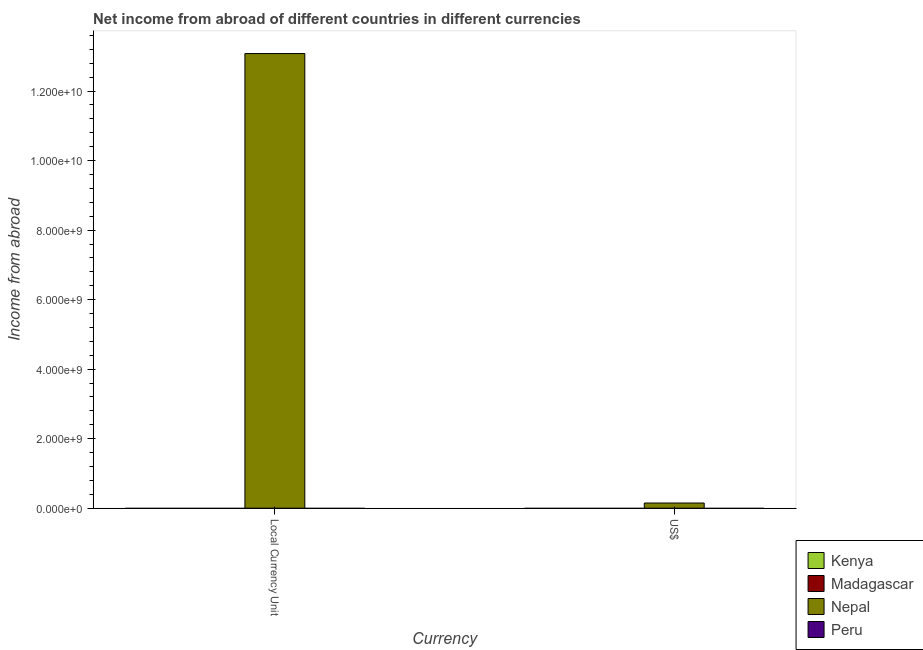How many different coloured bars are there?
Your response must be concise. 1. Are the number of bars per tick equal to the number of legend labels?
Ensure brevity in your answer.  No. What is the label of the 2nd group of bars from the left?
Offer a terse response. US$. What is the income from abroad in constant 2005 us$ in Peru?
Keep it short and to the point. 0. Across all countries, what is the maximum income from abroad in us$?
Your answer should be very brief. 1.49e+08. Across all countries, what is the minimum income from abroad in us$?
Give a very brief answer. 0. In which country was the income from abroad in constant 2005 us$ maximum?
Your answer should be compact. Nepal. What is the total income from abroad in constant 2005 us$ in the graph?
Provide a short and direct response. 1.31e+1. What is the difference between the income from abroad in us$ in Peru and the income from abroad in constant 2005 us$ in Kenya?
Keep it short and to the point. 0. What is the average income from abroad in us$ per country?
Ensure brevity in your answer.  3.72e+07. What is the difference between the income from abroad in constant 2005 us$ and income from abroad in us$ in Nepal?
Provide a short and direct response. 1.29e+1. In how many countries, is the income from abroad in constant 2005 us$ greater than 4000000000 units?
Ensure brevity in your answer.  1. Are the values on the major ticks of Y-axis written in scientific E-notation?
Your response must be concise. Yes. Does the graph contain any zero values?
Ensure brevity in your answer.  Yes. Does the graph contain grids?
Give a very brief answer. No. Where does the legend appear in the graph?
Keep it short and to the point. Bottom right. How are the legend labels stacked?
Offer a very short reply. Vertical. What is the title of the graph?
Offer a terse response. Net income from abroad of different countries in different currencies. What is the label or title of the X-axis?
Offer a very short reply. Currency. What is the label or title of the Y-axis?
Give a very brief answer. Income from abroad. What is the Income from abroad in Nepal in Local Currency Unit?
Provide a short and direct response. 1.31e+1. What is the Income from abroad in Peru in Local Currency Unit?
Offer a terse response. 0. What is the Income from abroad of Nepal in US$?
Give a very brief answer. 1.49e+08. Across all Currency, what is the maximum Income from abroad in Nepal?
Make the answer very short. 1.31e+1. Across all Currency, what is the minimum Income from abroad of Nepal?
Give a very brief answer. 1.49e+08. What is the total Income from abroad of Kenya in the graph?
Give a very brief answer. 0. What is the total Income from abroad in Nepal in the graph?
Provide a short and direct response. 1.32e+1. What is the difference between the Income from abroad of Nepal in Local Currency Unit and that in US$?
Your answer should be compact. 1.29e+1. What is the average Income from abroad in Kenya per Currency?
Make the answer very short. 0. What is the average Income from abroad of Nepal per Currency?
Your answer should be compact. 6.61e+09. What is the average Income from abroad in Peru per Currency?
Offer a very short reply. 0. What is the ratio of the Income from abroad of Nepal in Local Currency Unit to that in US$?
Your answer should be compact. 87.96. What is the difference between the highest and the second highest Income from abroad of Nepal?
Offer a very short reply. 1.29e+1. What is the difference between the highest and the lowest Income from abroad in Nepal?
Make the answer very short. 1.29e+1. 